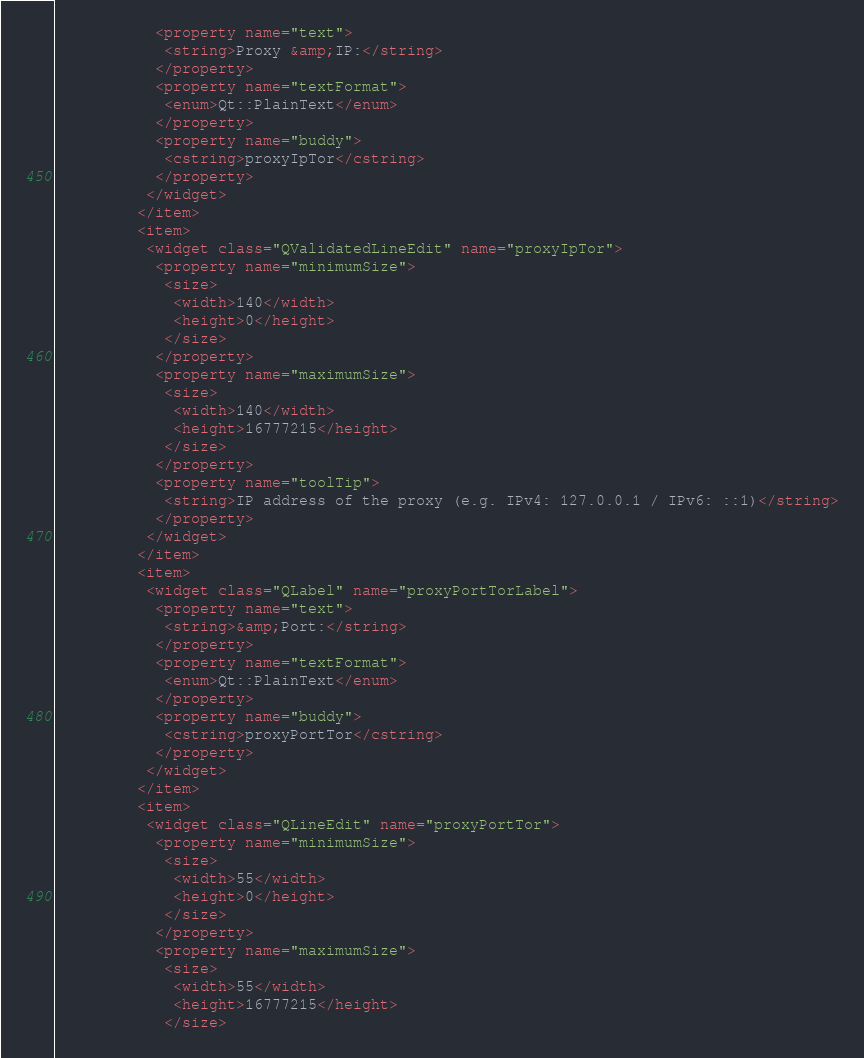Convert code to text. <code><loc_0><loc_0><loc_500><loc_500><_XML_>           <property name="text">
            <string>Proxy &amp;IP:</string>
           </property>
           <property name="textFormat">
            <enum>Qt::PlainText</enum>
           </property>
           <property name="buddy">
            <cstring>proxyIpTor</cstring>
           </property>
          </widget>
         </item>
         <item>
          <widget class="QValidatedLineEdit" name="proxyIpTor">
           <property name="minimumSize">
            <size>
             <width>140</width>
             <height>0</height>
            </size>
           </property>
           <property name="maximumSize">
            <size>
             <width>140</width>
             <height>16777215</height>
            </size>
           </property>
           <property name="toolTip">
            <string>IP address of the proxy (e.g. IPv4: 127.0.0.1 / IPv6: ::1)</string>
           </property>
          </widget>
         </item>
         <item>
          <widget class="QLabel" name="proxyPortTorLabel">
           <property name="text">
            <string>&amp;Port:</string>
           </property>
           <property name="textFormat">
            <enum>Qt::PlainText</enum>
           </property>
           <property name="buddy">
            <cstring>proxyPortTor</cstring>
           </property>
          </widget>
         </item>
         <item>
          <widget class="QLineEdit" name="proxyPortTor">
           <property name="minimumSize">
            <size>
             <width>55</width>
             <height>0</height>
            </size>
           </property>
           <property name="maximumSize">
            <size>
             <width>55</width>
             <height>16777215</height>
            </size></code> 